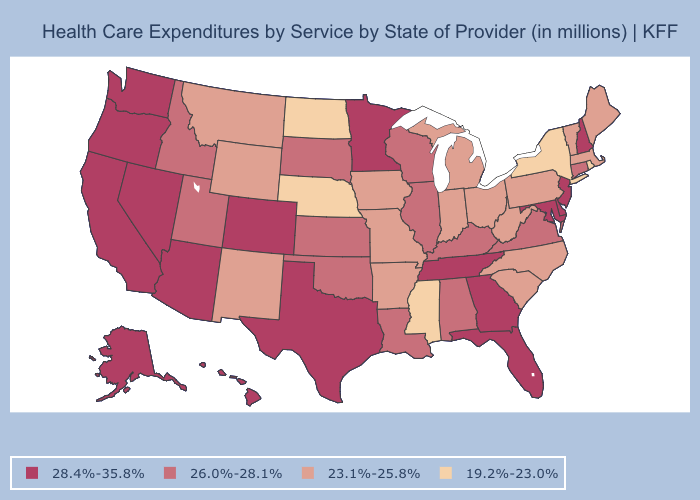Does Nebraska have the same value as Mississippi?
Write a very short answer. Yes. Does Florida have a higher value than Wisconsin?
Write a very short answer. Yes. What is the value of Wyoming?
Short answer required. 23.1%-25.8%. Is the legend a continuous bar?
Keep it brief. No. What is the value of North Carolina?
Concise answer only. 23.1%-25.8%. What is the lowest value in the USA?
Be succinct. 19.2%-23.0%. Does South Dakota have the highest value in the USA?
Answer briefly. No. Name the states that have a value in the range 28.4%-35.8%?
Keep it brief. Alaska, Arizona, California, Colorado, Delaware, Florida, Georgia, Hawaii, Maryland, Minnesota, Nevada, New Hampshire, New Jersey, Oregon, Tennessee, Texas, Washington. What is the value of Utah?
Write a very short answer. 26.0%-28.1%. Name the states that have a value in the range 19.2%-23.0%?
Write a very short answer. Mississippi, Nebraska, New York, North Dakota, Rhode Island. Does the map have missing data?
Quick response, please. No. Does Illinois have a lower value than Hawaii?
Write a very short answer. Yes. Name the states that have a value in the range 19.2%-23.0%?
Keep it brief. Mississippi, Nebraska, New York, North Dakota, Rhode Island. Name the states that have a value in the range 28.4%-35.8%?
Quick response, please. Alaska, Arizona, California, Colorado, Delaware, Florida, Georgia, Hawaii, Maryland, Minnesota, Nevada, New Hampshire, New Jersey, Oregon, Tennessee, Texas, Washington. Does Oklahoma have the lowest value in the USA?
Write a very short answer. No. 